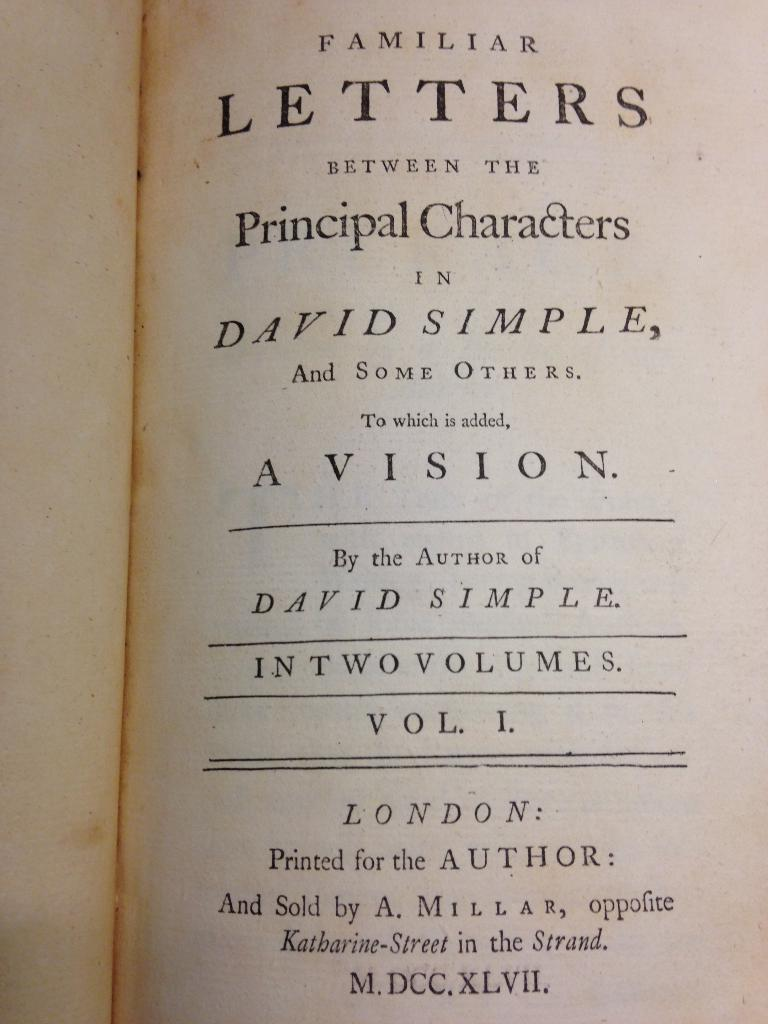<image>
Render a clear and concise summary of the photo. The author of this book is called David Simple. 